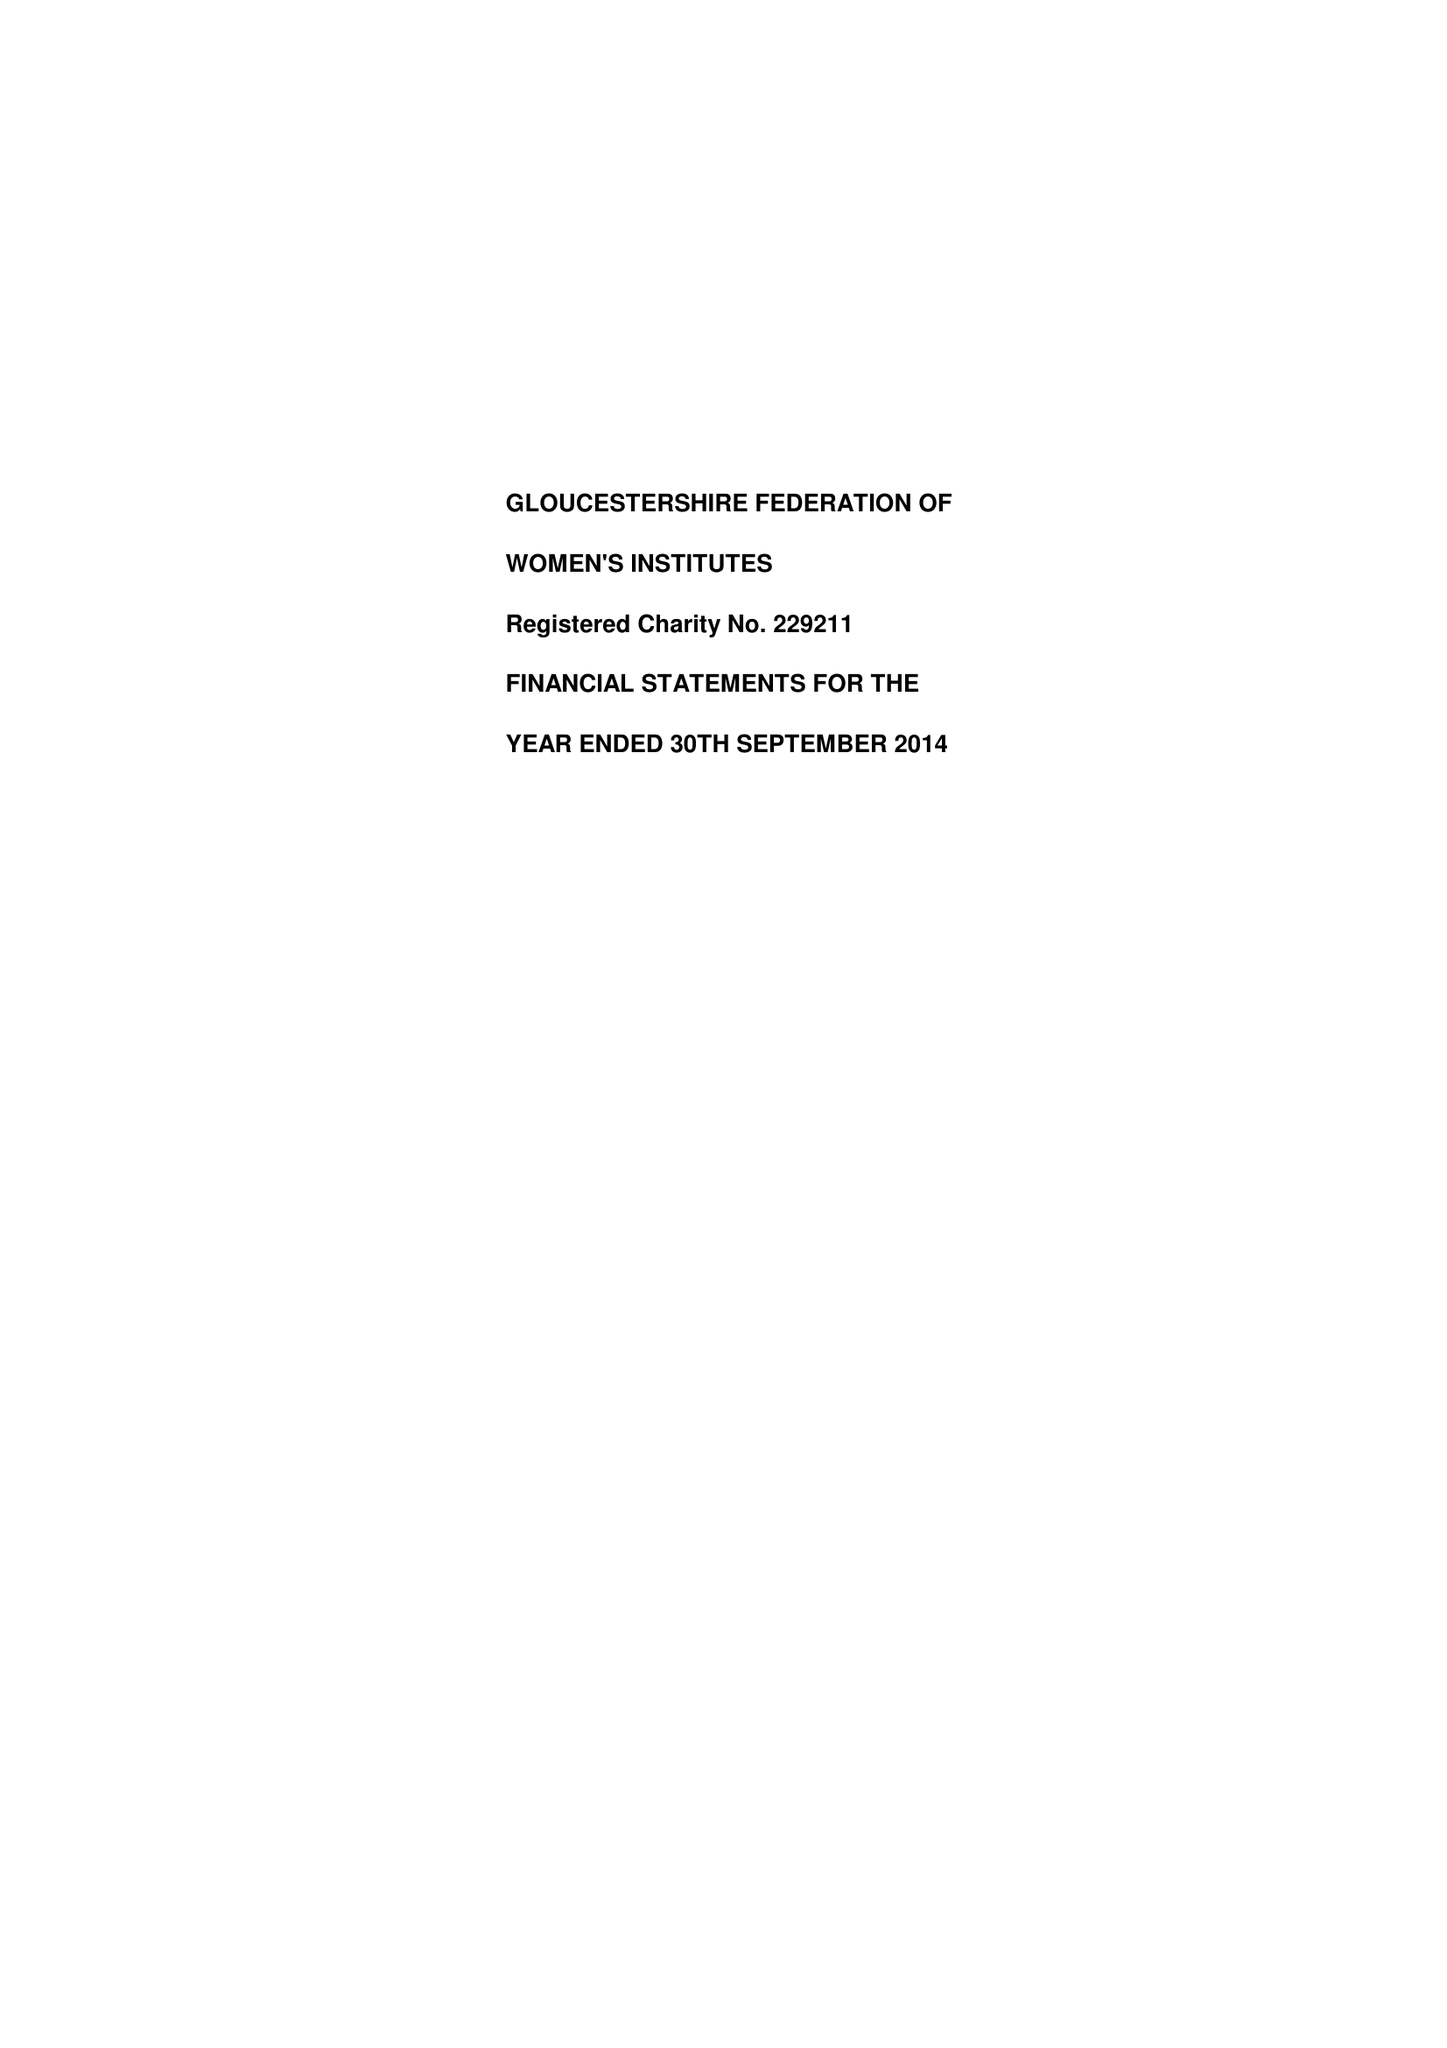What is the value for the address__postcode?
Answer the question using a single word or phrase. GL1 1UL 